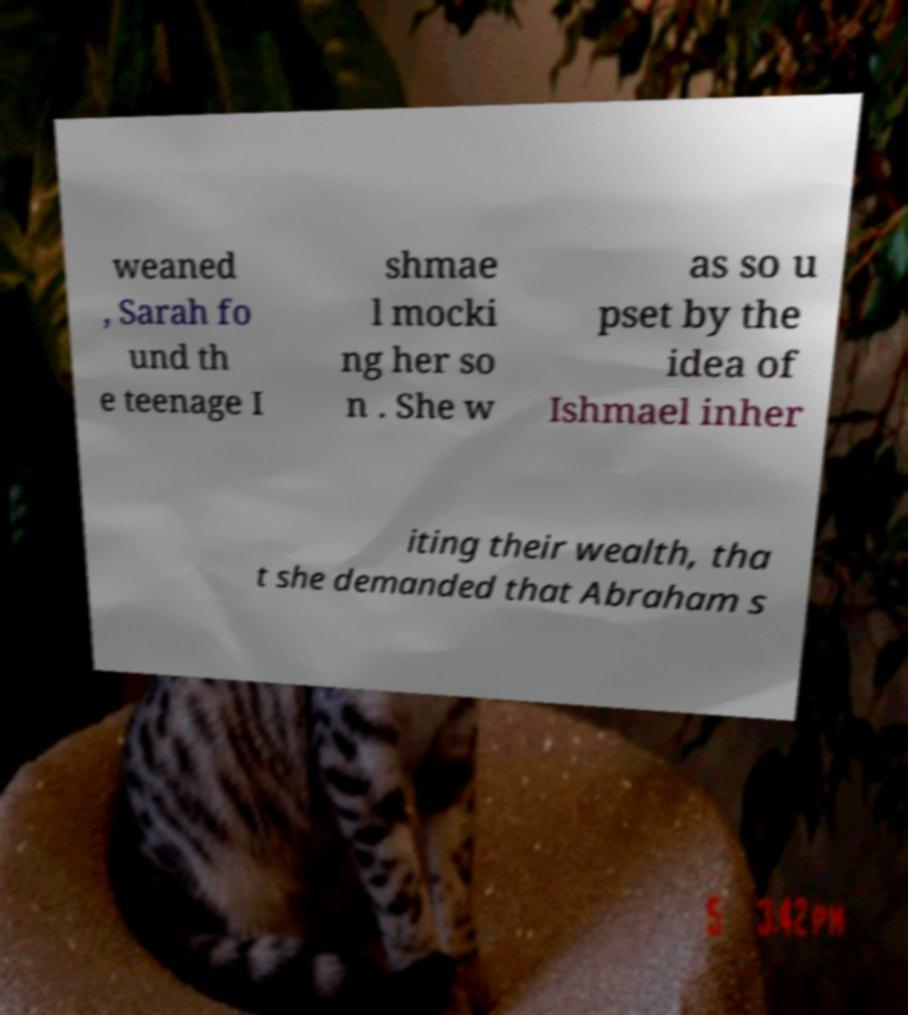Can you accurately transcribe the text from the provided image for me? weaned , Sarah fo und th e teenage I shmae l mocki ng her so n . She w as so u pset by the idea of Ishmael inher iting their wealth, tha t she demanded that Abraham s 